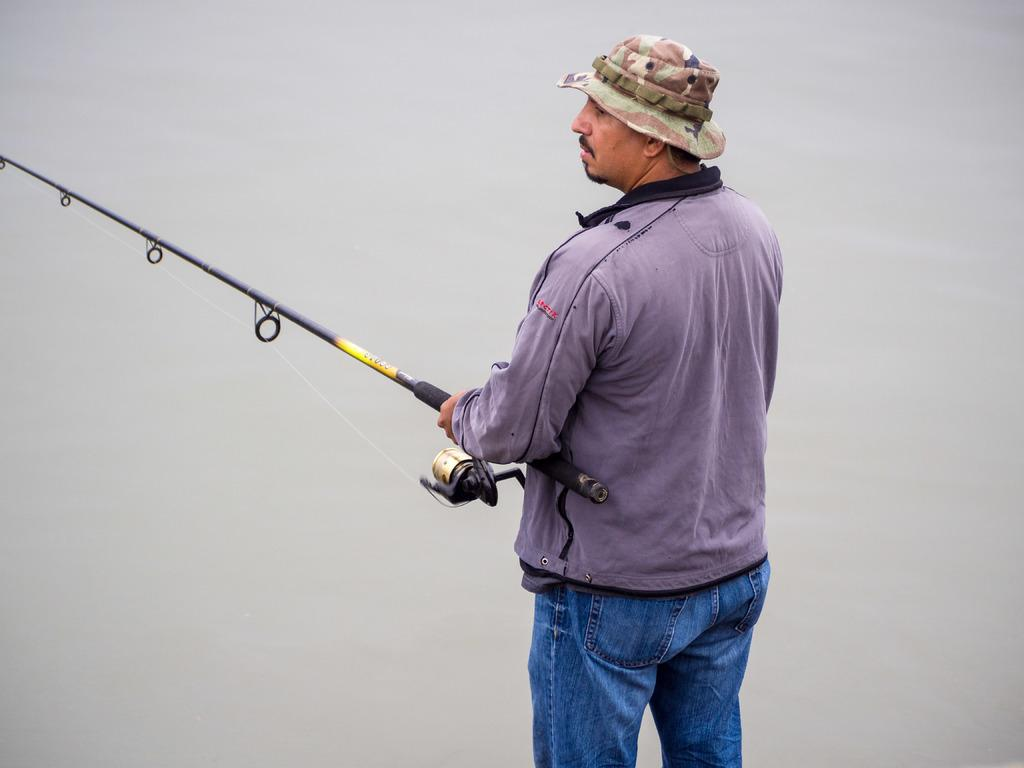Who is the main subject in the image? There is a man in the image. Where is the man located in the image? The man is standing in the center of the image. What is the man holding in the image? The man is holding a fishing rod. What type of cart can be seen in the image? There is no cart present in the image; it features a man holding a fishing rod. What kind of dirt is visible on the ground in the image? There is no dirt visible on the ground in the image; it appears to be a clean surface. 